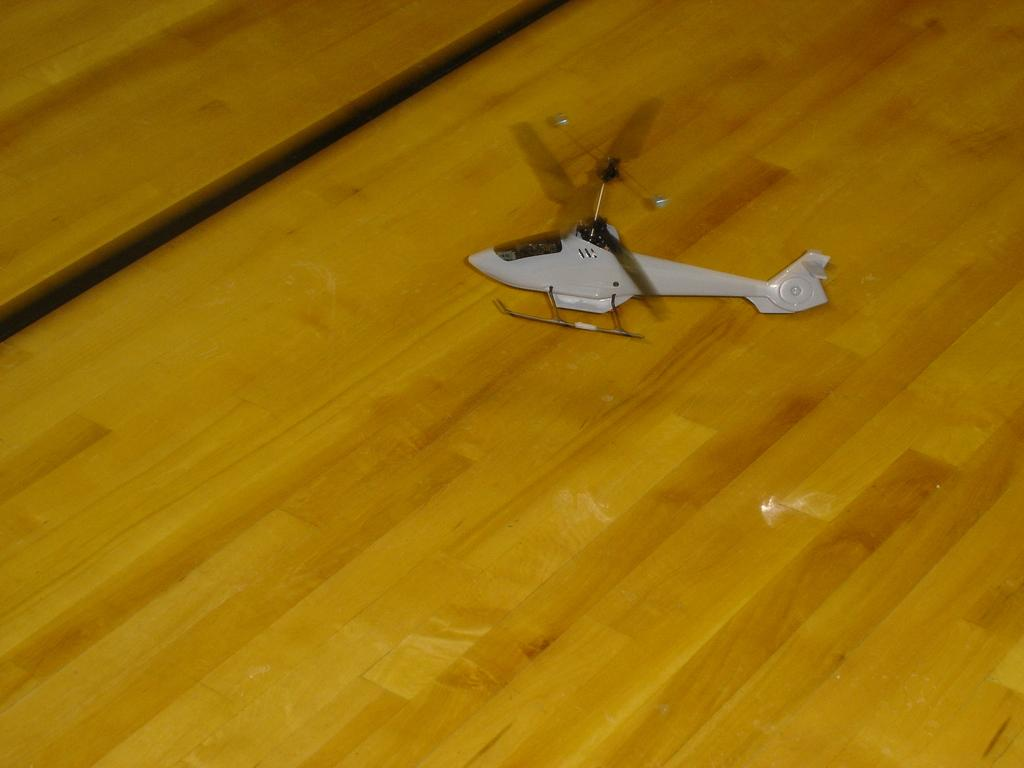What is the main subject of the image? The main subject of the image is a helicopter. Where is the helicopter located in the image? The helicopter is on a table in the image. What type of thumb is visible on the helicopter in the image? There is no thumb present on the helicopter in the image. What type of secretary is working on the helicopter in the image? There is no secretary present in the image, and the helicopter is not being worked on. 